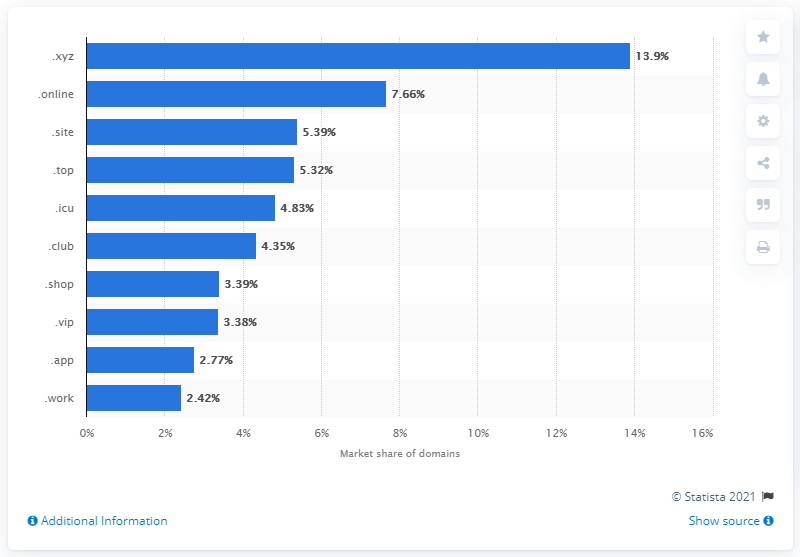Outline some significant characteristics in this image. In 2019, the leading new generic top-level domain (gTLD) was .xyz. As of April 2021, the market share of ".site" domains was 5.39%. 